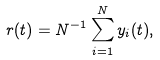<formula> <loc_0><loc_0><loc_500><loc_500>r ( t ) = N ^ { - 1 } \sum _ { i = 1 } ^ { N } y _ { i } ( t ) ,</formula> 